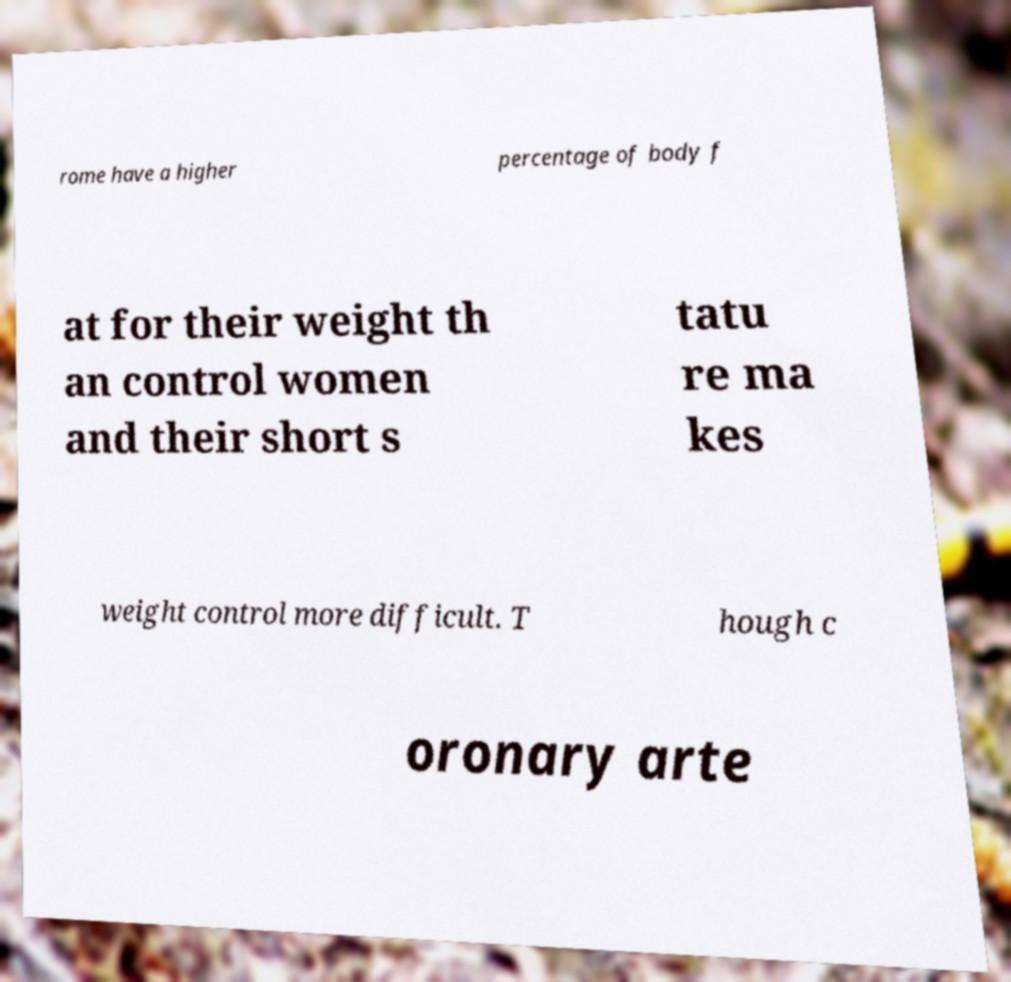There's text embedded in this image that I need extracted. Can you transcribe it verbatim? rome have a higher percentage of body f at for their weight th an control women and their short s tatu re ma kes weight control more difficult. T hough c oronary arte 